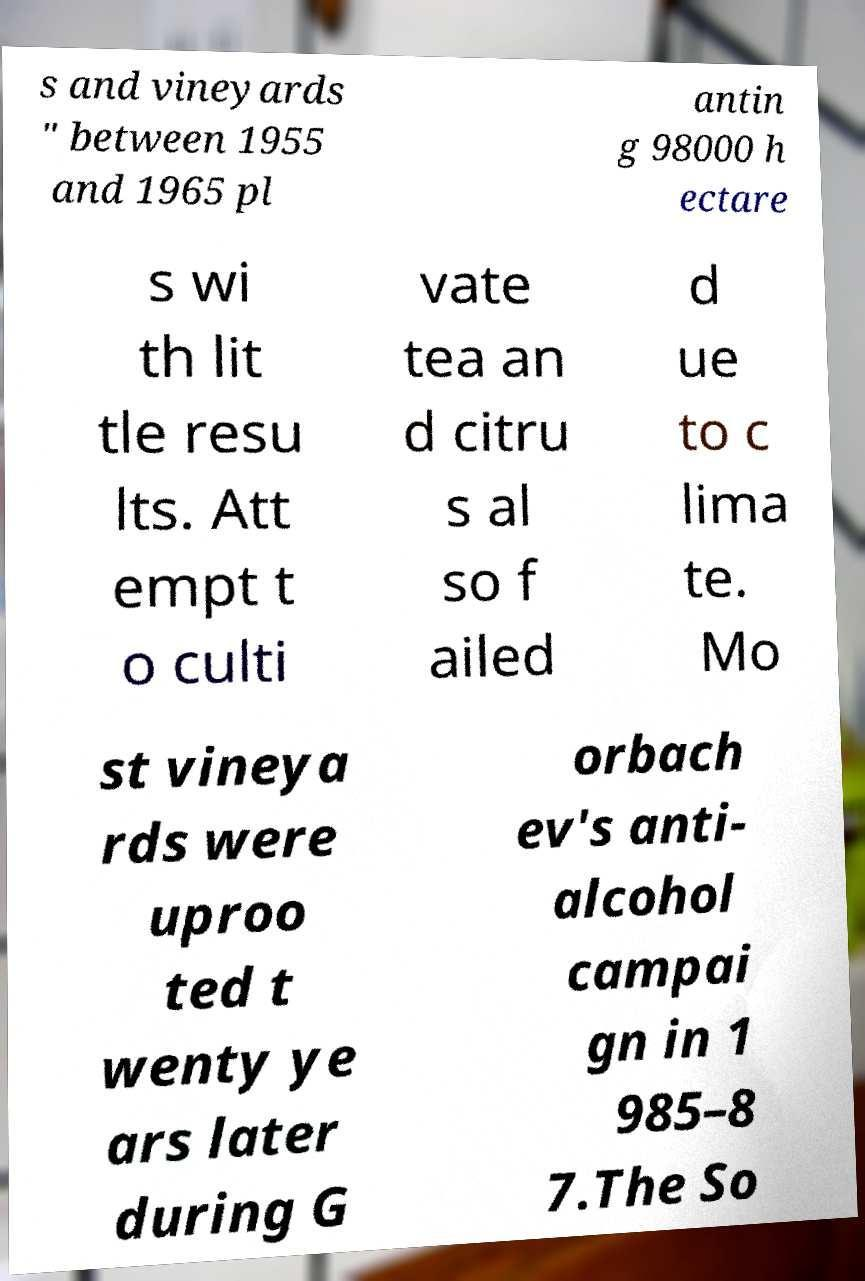I need the written content from this picture converted into text. Can you do that? s and vineyards " between 1955 and 1965 pl antin g 98000 h ectare s wi th lit tle resu lts. Att empt t o culti vate tea an d citru s al so f ailed d ue to c lima te. Mo st vineya rds were uproo ted t wenty ye ars later during G orbach ev's anti- alcohol campai gn in 1 985–8 7.The So 